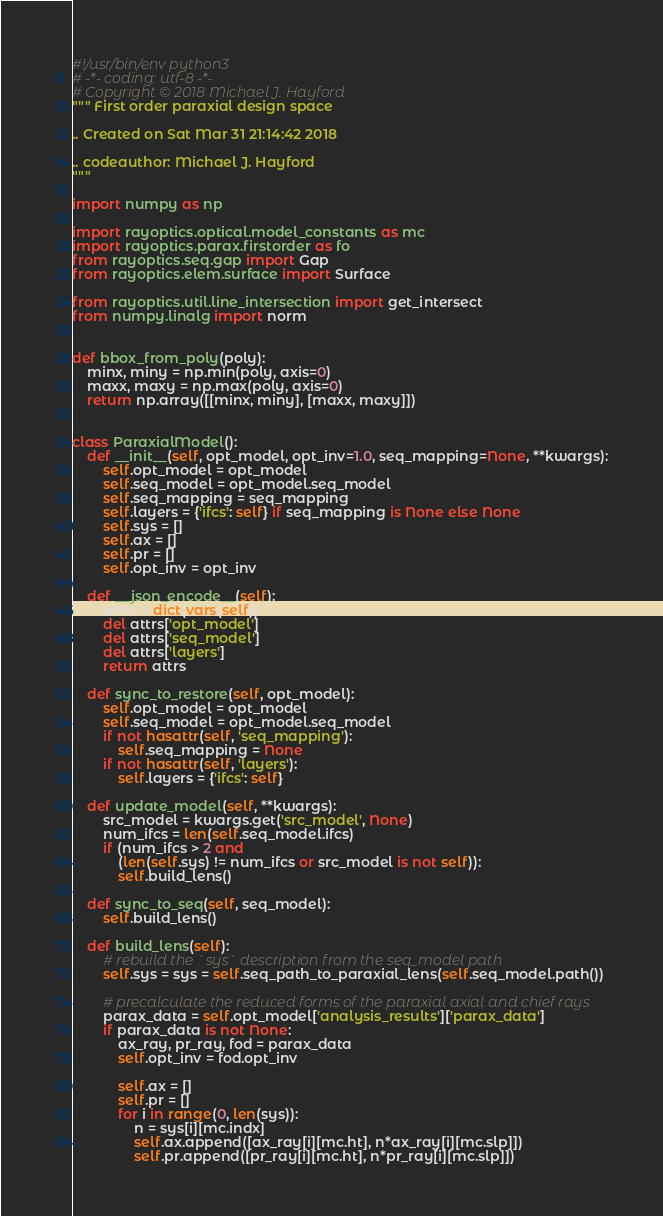<code> <loc_0><loc_0><loc_500><loc_500><_Python_>#!/usr/bin/env python3
# -*- coding: utf-8 -*-
# Copyright © 2018 Michael J. Hayford
""" First order paraxial design space

.. Created on Sat Mar 31 21:14:42 2018

.. codeauthor: Michael J. Hayford
"""

import numpy as np

import rayoptics.optical.model_constants as mc
import rayoptics.parax.firstorder as fo
from rayoptics.seq.gap import Gap
from rayoptics.elem.surface import Surface

from rayoptics.util.line_intersection import get_intersect
from numpy.linalg import norm


def bbox_from_poly(poly):
    minx, miny = np.min(poly, axis=0)
    maxx, maxy = np.max(poly, axis=0)
    return np.array([[minx, miny], [maxx, maxy]])


class ParaxialModel():
    def __init__(self, opt_model, opt_inv=1.0, seq_mapping=None, **kwargs):
        self.opt_model = opt_model
        self.seq_model = opt_model.seq_model
        self.seq_mapping = seq_mapping
        self.layers = {'ifcs': self} if seq_mapping is None else None
        self.sys = []
        self.ax = []
        self.pr = []
        self.opt_inv = opt_inv

    def __json_encode__(self):
        attrs = dict(vars(self))
        del attrs['opt_model']
        del attrs['seq_model']
        del attrs['layers']
        return attrs

    def sync_to_restore(self, opt_model):
        self.opt_model = opt_model
        self.seq_model = opt_model.seq_model
        if not hasattr(self, 'seq_mapping'):
            self.seq_mapping = None
        if not hasattr(self, 'layers'):
            self.layers = {'ifcs': self}

    def update_model(self, **kwargs):
        src_model = kwargs.get('src_model', None)
        num_ifcs = len(self.seq_model.ifcs)
        if (num_ifcs > 2 and 
            (len(self.sys) != num_ifcs or src_model is not self)):
            self.build_lens()

    def sync_to_seq(self, seq_model):
        self.build_lens()

    def build_lens(self):
        # rebuild the `sys` description from the seq_model path
        self.sys = sys = self.seq_path_to_paraxial_lens(self.seq_model.path())

        # precalculate the reduced forms of the paraxial axial and chief rays
        parax_data = self.opt_model['analysis_results']['parax_data']
        if parax_data is not None:
            ax_ray, pr_ray, fod = parax_data
            self.opt_inv = fod.opt_inv
    
            self.ax = []
            self.pr = []
            for i in range(0, len(sys)):
                n = sys[i][mc.indx]
                self.ax.append([ax_ray[i][mc.ht], n*ax_ray[i][mc.slp]])
                self.pr.append([pr_ray[i][mc.ht], n*pr_ray[i][mc.slp]])
</code> 